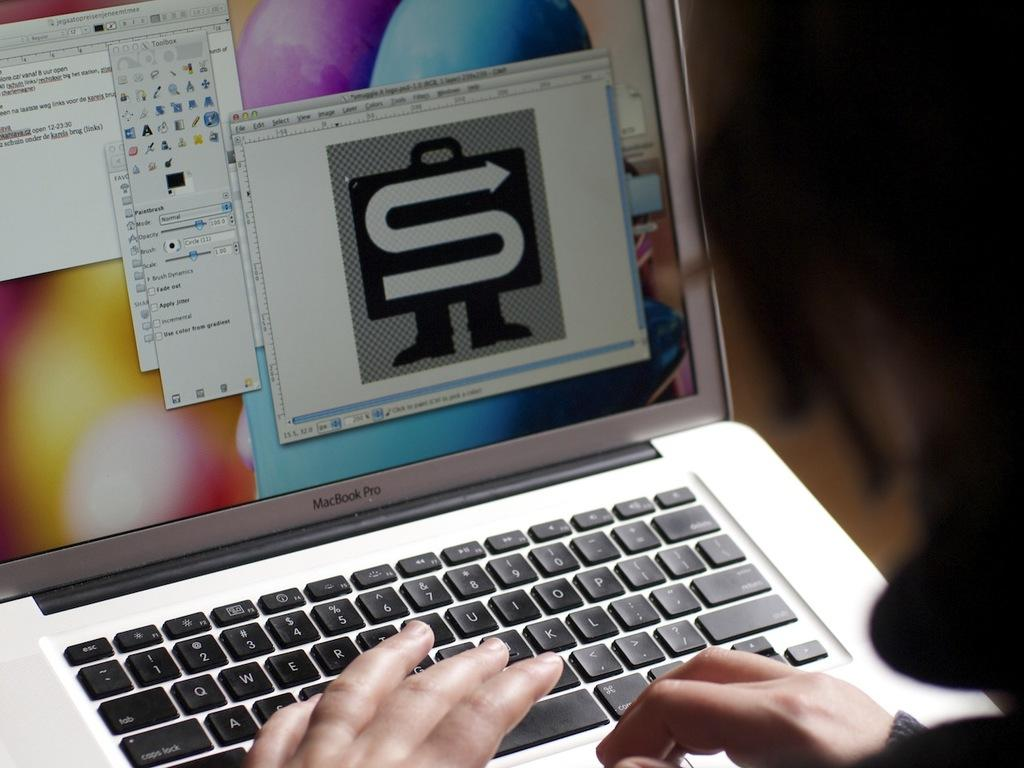<image>
Relay a brief, clear account of the picture shown. A MacBrook Pro laptop open with graphics and screens open on the display. 